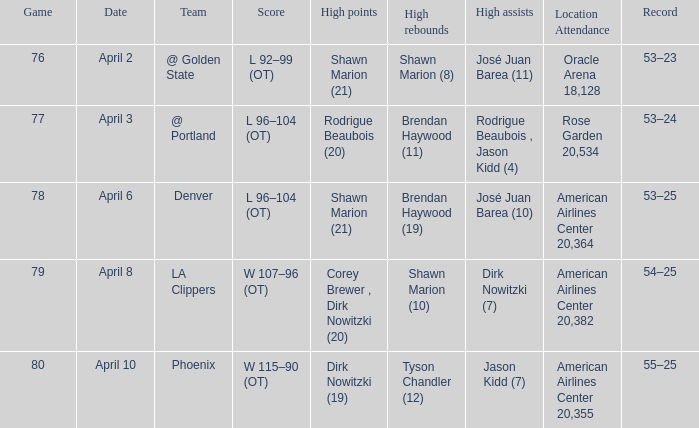What is the contest number held on april 3? 77.0. 